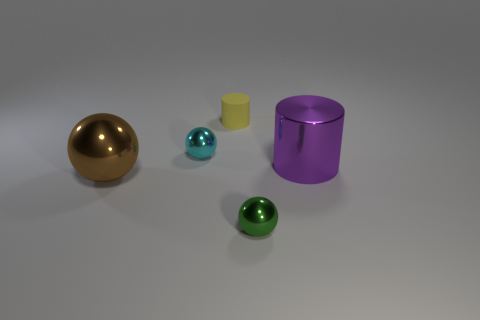Do the yellow cylinder and the metallic sphere that is behind the large metallic cylinder have the same size?
Ensure brevity in your answer.  Yes. Is there a small green object made of the same material as the cyan thing?
Keep it short and to the point. Yes. What number of blocks are tiny red objects or small green objects?
Your response must be concise. 0. There is a yellow matte thing that is on the right side of the large brown object; is there a big purple object that is to the left of it?
Ensure brevity in your answer.  No. Are there fewer large objects than tiny cyan balls?
Provide a short and direct response. No. How many other big objects are the same shape as the yellow matte object?
Give a very brief answer. 1. What number of cyan things are big spheres or small shiny spheres?
Your answer should be compact. 1. What size is the purple object behind the big shiny object that is on the left side of the tiny matte cylinder?
Provide a short and direct response. Large. There is a tiny cyan object that is the same shape as the tiny green object; what is its material?
Make the answer very short. Metal. What number of red cylinders have the same size as the purple metal cylinder?
Offer a very short reply. 0. 